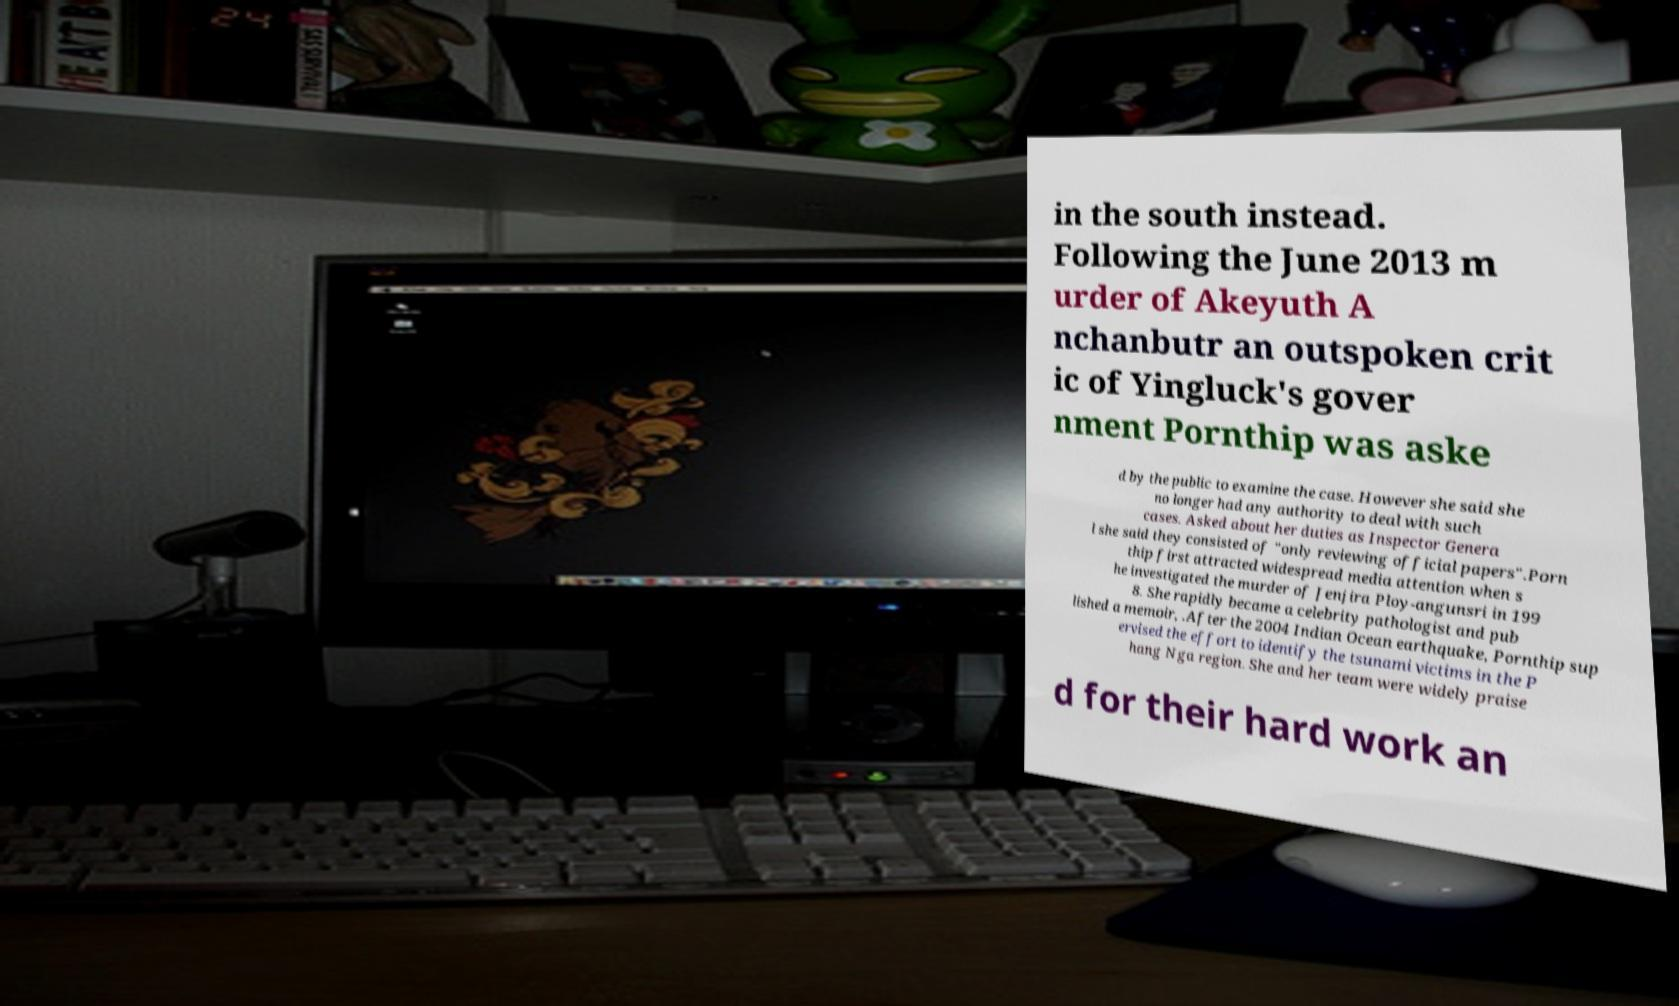What messages or text are displayed in this image? I need them in a readable, typed format. in the south instead. Following the June 2013 m urder of Akeyuth A nchanbutr an outspoken crit ic of Yingluck's gover nment Pornthip was aske d by the public to examine the case. However she said she no longer had any authority to deal with such cases. Asked about her duties as Inspector Genera l she said they consisted of "only reviewing official papers".Porn thip first attracted widespread media attention when s he investigated the murder of Jenjira Ploy-angunsri in 199 8. She rapidly became a celebrity pathologist and pub lished a memoir, .After the 2004 Indian Ocean earthquake, Pornthip sup ervised the effort to identify the tsunami victims in the P hang Nga region. She and her team were widely praise d for their hard work an 